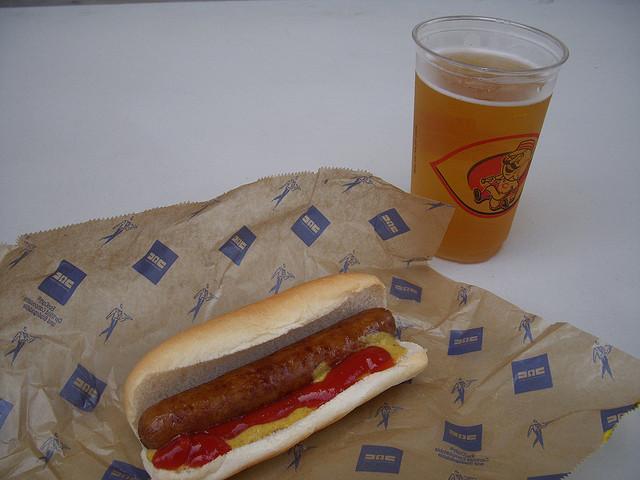How many hot dogs can be seen?
Give a very brief answer. 1. How many bowls in the image contain broccoli?
Give a very brief answer. 0. 